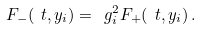Convert formula to latex. <formula><loc_0><loc_0><loc_500><loc_500>F _ { - } ( \ t , y _ { i } ) = \ g _ { i } ^ { 2 } F _ { + } ( \ t , y _ { i } ) \, .</formula> 